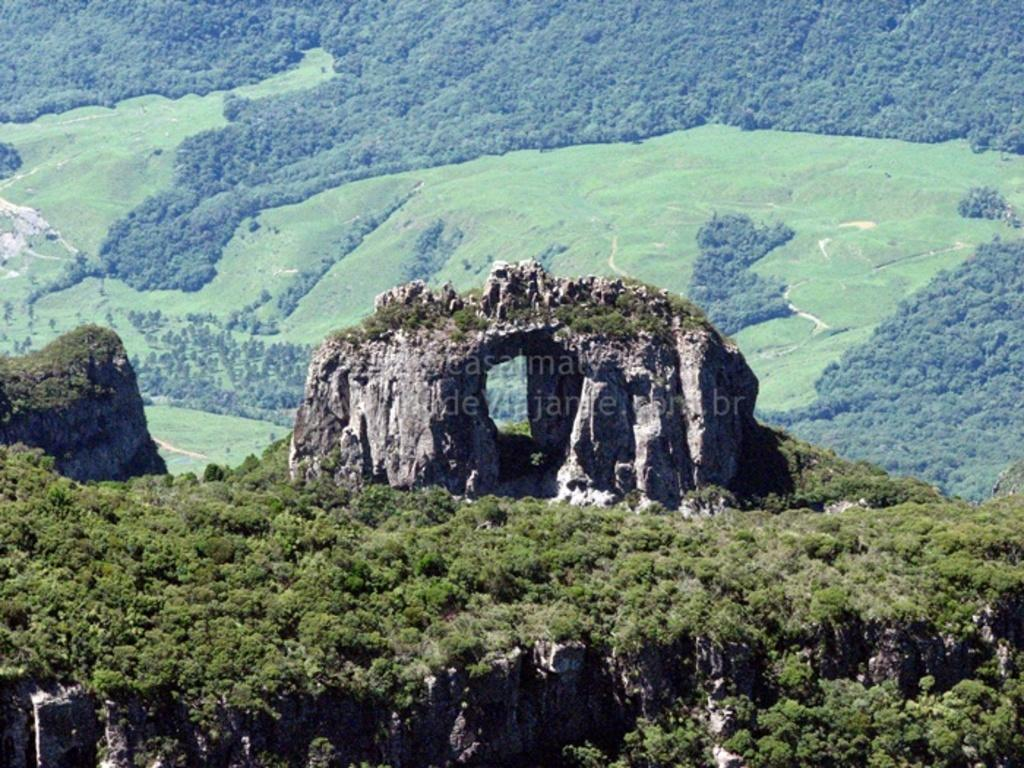What is the main subject of the image? The main subject of the image is a huge rock. Where is the rock located? The rock is on a hill. What can be seen around the rock? There is a lot of greenery around the rock. What is visible in the background of the image? There is a grass surface and trees visible in the background of the image. What type of rhythm can be heard coming from the apple in the image? There is no apple present in the image, and therefore no rhythm can be heard. 